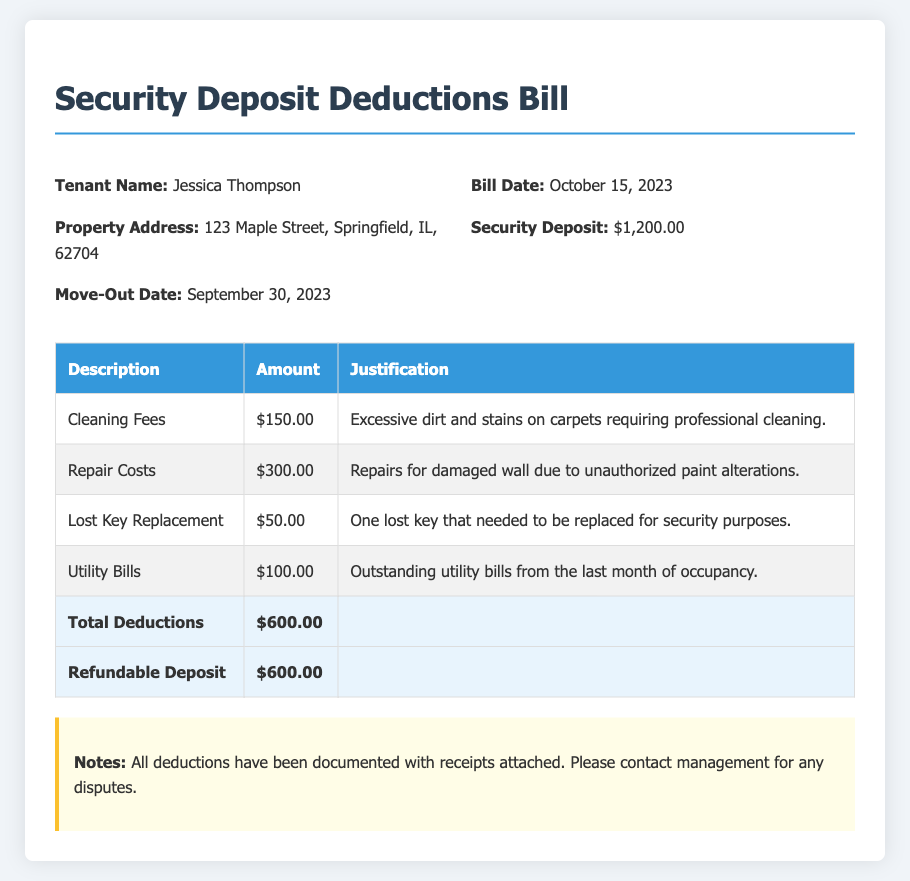What is the tenant's name? The tenant's name is listed at the top of the bill for easy reference, which is Jessica Thompson.
Answer: Jessica Thompson What is the property address? The property address provides the location of the rental property, listed as 123 Maple Street, Springfield, IL, 62704.
Answer: 123 Maple Street, Springfield, IL, 62704 What is the total amount deducted from the security deposit? The total deductions from the security deposit are clearly stated in the table as $600.00.
Answer: $600.00 What is the refundable deposit amount? The document specifies the refundable deposit amount after deductions, which is also listed as $600.00.
Answer: $600.00 What date was the bill issued? The bill date is provided on the document to indicate when the charges were final, which is October 15, 2023.
Answer: October 15, 2023 How much was charged for cleaning fees? The charge for cleaning fees is detailed in the deductions table as a specific line item amounting to $150.00.
Answer: $150.00 What justification is given for the repair costs? The document outlines the reason for the repair charges, which involves unauthorized paint alterations resulting in damage.
Answer: Unauthorized paint alterations What does the notes section indicate about disputes? The notes section specifies a contact point for disputes regarding the deductions listed, indicating management should be contacted.
Answer: Contact management What was the move-out date for the tenant? The move-out date is provided as a significant event defining the timeline of the tenancy, which is September 30, 2023.
Answer: September 30, 2023 